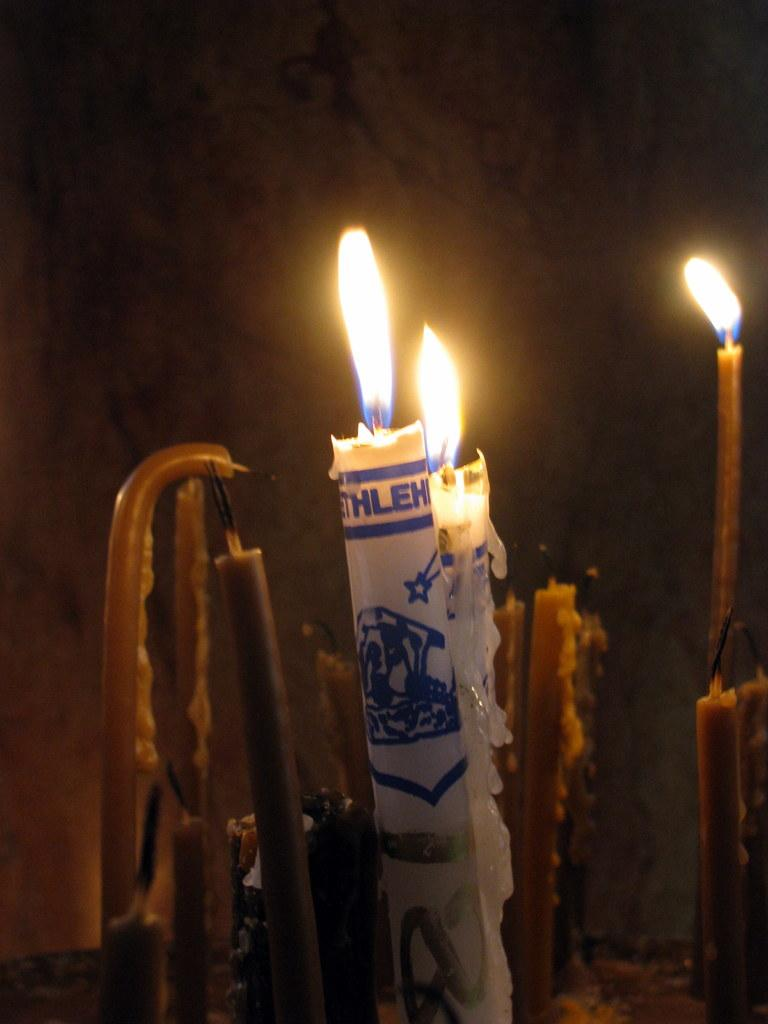What objects can be seen in the image? There are candles in the image. What is happening to some of the candles? Some of the candles are blowing. What type of committee is meeting on the sidewalk in the image? There is no committee or sidewalk present in the image; it only features candles. What muscle is being exercised by the candles in the image? Candles do not have muscles, so this question is not applicable to the image. 